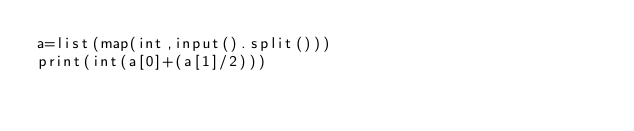<code> <loc_0><loc_0><loc_500><loc_500><_Python_>a=list(map(int,input().split()))
print(int(a[0]+(a[1]/2)))</code> 